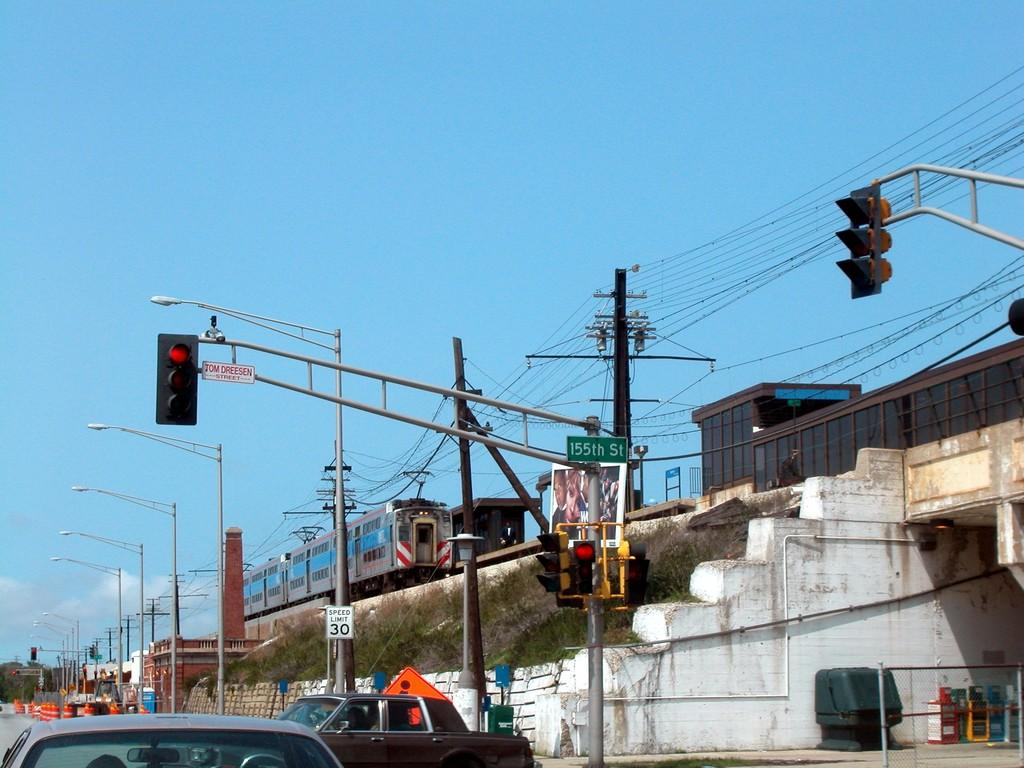<image>
Offer a succinct explanation of the picture presented. The speed limit for the road by the train tracks is 30 mph. 